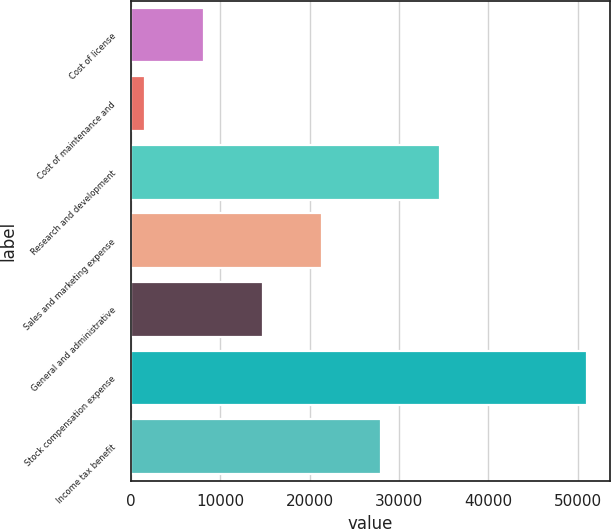<chart> <loc_0><loc_0><loc_500><loc_500><bar_chart><fcel>Cost of license<fcel>Cost of maintenance and<fcel>Research and development<fcel>Sales and marketing expense<fcel>General and administrative<fcel>Stock compensation expense<fcel>Income tax benefit<nl><fcel>8216.3<fcel>1628<fcel>34569.5<fcel>21392.9<fcel>14804.6<fcel>51065<fcel>27981.2<nl></chart> 